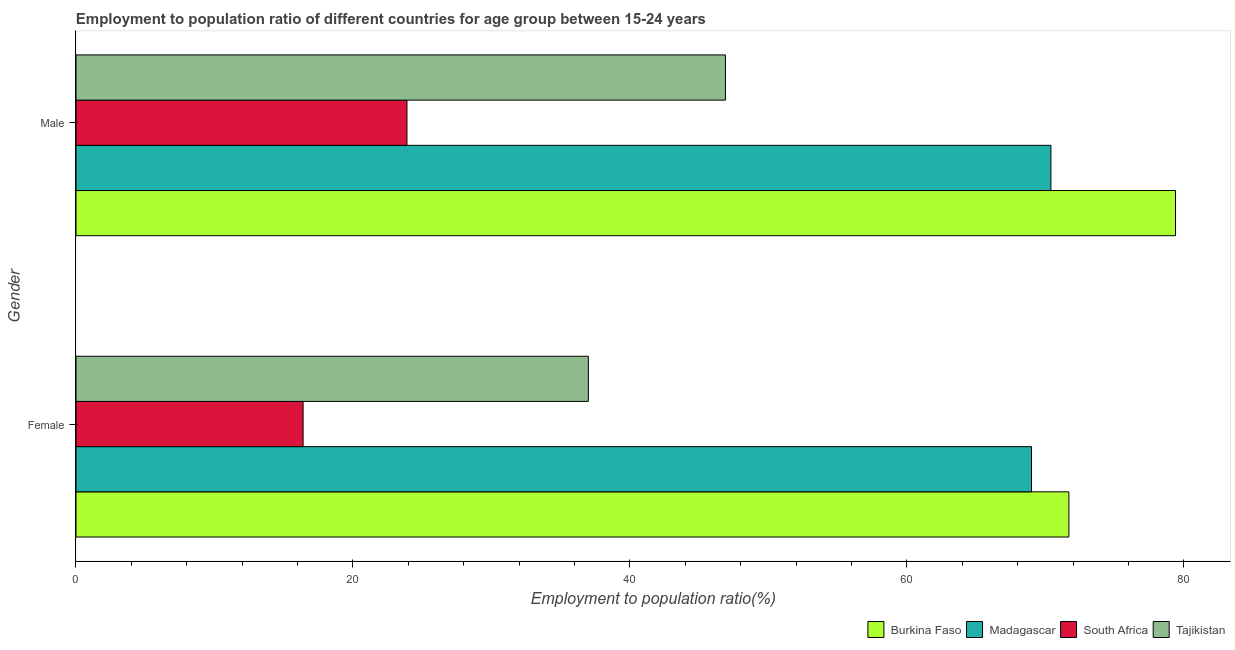How many different coloured bars are there?
Make the answer very short. 4. Are the number of bars per tick equal to the number of legend labels?
Keep it short and to the point. Yes. How many bars are there on the 2nd tick from the top?
Your response must be concise. 4. What is the label of the 2nd group of bars from the top?
Give a very brief answer. Female. What is the employment to population ratio(male) in Burkina Faso?
Provide a succinct answer. 79.4. Across all countries, what is the maximum employment to population ratio(female)?
Provide a short and direct response. 71.7. Across all countries, what is the minimum employment to population ratio(male)?
Your answer should be very brief. 23.9. In which country was the employment to population ratio(male) maximum?
Your answer should be compact. Burkina Faso. In which country was the employment to population ratio(male) minimum?
Give a very brief answer. South Africa. What is the total employment to population ratio(female) in the graph?
Your response must be concise. 194.1. What is the difference between the employment to population ratio(male) in South Africa and that in Tajikistan?
Ensure brevity in your answer.  -23. What is the difference between the employment to population ratio(female) in Burkina Faso and the employment to population ratio(male) in Tajikistan?
Provide a short and direct response. 24.8. What is the average employment to population ratio(female) per country?
Offer a terse response. 48.52. What is the difference between the employment to population ratio(female) and employment to population ratio(male) in Burkina Faso?
Offer a terse response. -7.7. What is the ratio of the employment to population ratio(female) in Madagascar to that in South Africa?
Offer a very short reply. 4.21. Is the employment to population ratio(female) in Tajikistan less than that in Madagascar?
Your response must be concise. Yes. What does the 4th bar from the top in Male represents?
Offer a very short reply. Burkina Faso. What does the 1st bar from the bottom in Female represents?
Give a very brief answer. Burkina Faso. How many countries are there in the graph?
Provide a short and direct response. 4. What is the difference between two consecutive major ticks on the X-axis?
Offer a very short reply. 20. Are the values on the major ticks of X-axis written in scientific E-notation?
Give a very brief answer. No. Does the graph contain grids?
Make the answer very short. No. Where does the legend appear in the graph?
Your answer should be very brief. Bottom right. How many legend labels are there?
Your response must be concise. 4. What is the title of the graph?
Keep it short and to the point. Employment to population ratio of different countries for age group between 15-24 years. What is the label or title of the Y-axis?
Keep it short and to the point. Gender. What is the Employment to population ratio(%) of Burkina Faso in Female?
Offer a terse response. 71.7. What is the Employment to population ratio(%) in South Africa in Female?
Your response must be concise. 16.4. What is the Employment to population ratio(%) of Burkina Faso in Male?
Ensure brevity in your answer.  79.4. What is the Employment to population ratio(%) in Madagascar in Male?
Make the answer very short. 70.4. What is the Employment to population ratio(%) of South Africa in Male?
Offer a terse response. 23.9. What is the Employment to population ratio(%) of Tajikistan in Male?
Offer a terse response. 46.9. Across all Gender, what is the maximum Employment to population ratio(%) of Burkina Faso?
Your answer should be compact. 79.4. Across all Gender, what is the maximum Employment to population ratio(%) in Madagascar?
Provide a short and direct response. 70.4. Across all Gender, what is the maximum Employment to population ratio(%) of South Africa?
Your response must be concise. 23.9. Across all Gender, what is the maximum Employment to population ratio(%) of Tajikistan?
Provide a succinct answer. 46.9. Across all Gender, what is the minimum Employment to population ratio(%) in Burkina Faso?
Offer a terse response. 71.7. Across all Gender, what is the minimum Employment to population ratio(%) of South Africa?
Offer a terse response. 16.4. What is the total Employment to population ratio(%) in Burkina Faso in the graph?
Your answer should be compact. 151.1. What is the total Employment to population ratio(%) of Madagascar in the graph?
Your response must be concise. 139.4. What is the total Employment to population ratio(%) in South Africa in the graph?
Give a very brief answer. 40.3. What is the total Employment to population ratio(%) of Tajikistan in the graph?
Provide a succinct answer. 83.9. What is the difference between the Employment to population ratio(%) in South Africa in Female and that in Male?
Keep it short and to the point. -7.5. What is the difference between the Employment to population ratio(%) of Burkina Faso in Female and the Employment to population ratio(%) of Madagascar in Male?
Offer a very short reply. 1.3. What is the difference between the Employment to population ratio(%) in Burkina Faso in Female and the Employment to population ratio(%) in South Africa in Male?
Keep it short and to the point. 47.8. What is the difference between the Employment to population ratio(%) in Burkina Faso in Female and the Employment to population ratio(%) in Tajikistan in Male?
Ensure brevity in your answer.  24.8. What is the difference between the Employment to population ratio(%) of Madagascar in Female and the Employment to population ratio(%) of South Africa in Male?
Your answer should be very brief. 45.1. What is the difference between the Employment to population ratio(%) in Madagascar in Female and the Employment to population ratio(%) in Tajikistan in Male?
Offer a very short reply. 22.1. What is the difference between the Employment to population ratio(%) in South Africa in Female and the Employment to population ratio(%) in Tajikistan in Male?
Make the answer very short. -30.5. What is the average Employment to population ratio(%) of Burkina Faso per Gender?
Ensure brevity in your answer.  75.55. What is the average Employment to population ratio(%) in Madagascar per Gender?
Your answer should be very brief. 69.7. What is the average Employment to population ratio(%) of South Africa per Gender?
Offer a very short reply. 20.15. What is the average Employment to population ratio(%) of Tajikistan per Gender?
Your response must be concise. 41.95. What is the difference between the Employment to population ratio(%) of Burkina Faso and Employment to population ratio(%) of Madagascar in Female?
Provide a short and direct response. 2.7. What is the difference between the Employment to population ratio(%) of Burkina Faso and Employment to population ratio(%) of South Africa in Female?
Provide a short and direct response. 55.3. What is the difference between the Employment to population ratio(%) in Burkina Faso and Employment to population ratio(%) in Tajikistan in Female?
Provide a short and direct response. 34.7. What is the difference between the Employment to population ratio(%) of Madagascar and Employment to population ratio(%) of South Africa in Female?
Make the answer very short. 52.6. What is the difference between the Employment to population ratio(%) of South Africa and Employment to population ratio(%) of Tajikistan in Female?
Provide a short and direct response. -20.6. What is the difference between the Employment to population ratio(%) of Burkina Faso and Employment to population ratio(%) of South Africa in Male?
Ensure brevity in your answer.  55.5. What is the difference between the Employment to population ratio(%) of Burkina Faso and Employment to population ratio(%) of Tajikistan in Male?
Offer a very short reply. 32.5. What is the difference between the Employment to population ratio(%) in Madagascar and Employment to population ratio(%) in South Africa in Male?
Give a very brief answer. 46.5. What is the ratio of the Employment to population ratio(%) of Burkina Faso in Female to that in Male?
Offer a very short reply. 0.9. What is the ratio of the Employment to population ratio(%) of Madagascar in Female to that in Male?
Ensure brevity in your answer.  0.98. What is the ratio of the Employment to population ratio(%) in South Africa in Female to that in Male?
Give a very brief answer. 0.69. What is the ratio of the Employment to population ratio(%) of Tajikistan in Female to that in Male?
Ensure brevity in your answer.  0.79. What is the difference between the highest and the second highest Employment to population ratio(%) in Burkina Faso?
Your answer should be compact. 7.7. What is the difference between the highest and the second highest Employment to population ratio(%) in Madagascar?
Keep it short and to the point. 1.4. What is the difference between the highest and the second highest Employment to population ratio(%) of South Africa?
Offer a terse response. 7.5. What is the difference between the highest and the lowest Employment to population ratio(%) of Burkina Faso?
Your answer should be compact. 7.7. What is the difference between the highest and the lowest Employment to population ratio(%) in Madagascar?
Give a very brief answer. 1.4. What is the difference between the highest and the lowest Employment to population ratio(%) of Tajikistan?
Provide a short and direct response. 9.9. 